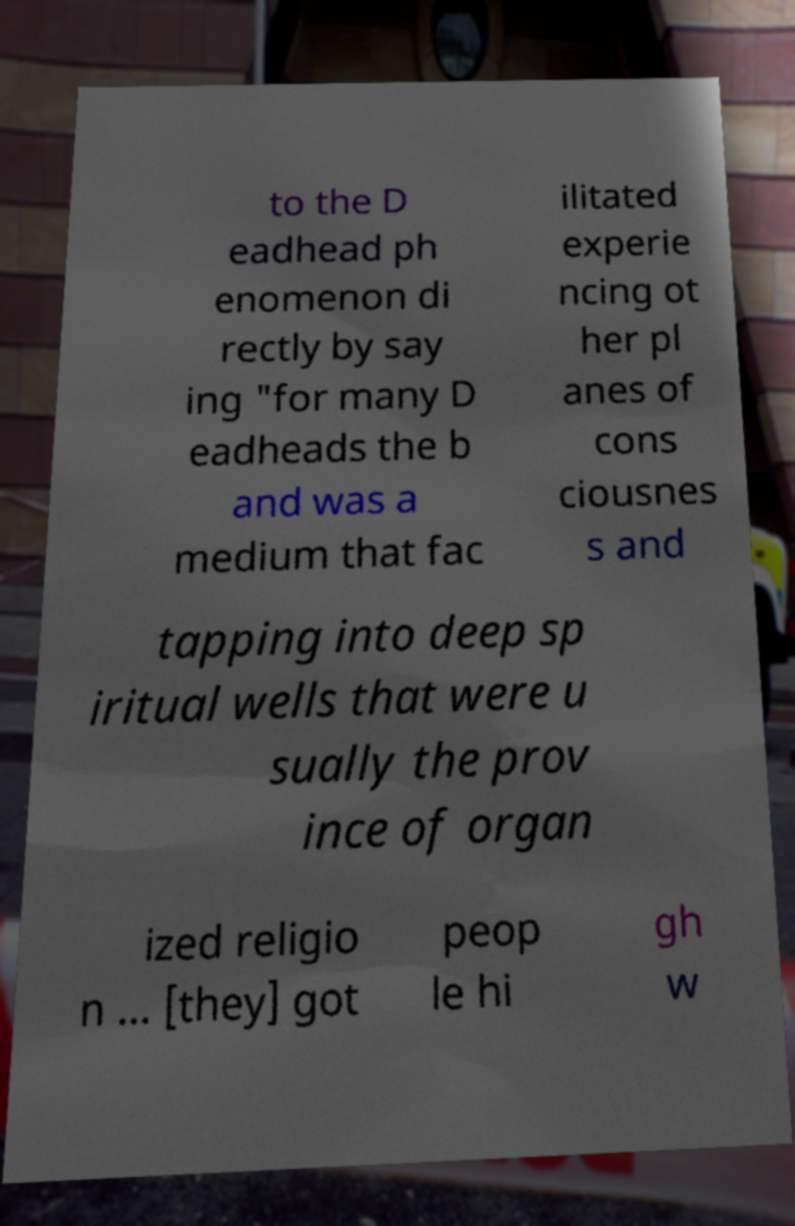Can you accurately transcribe the text from the provided image for me? to the D eadhead ph enomenon di rectly by say ing "for many D eadheads the b and was a medium that fac ilitated experie ncing ot her pl anes of cons ciousnes s and tapping into deep sp iritual wells that were u sually the prov ince of organ ized religio n ... [they] got peop le hi gh w 